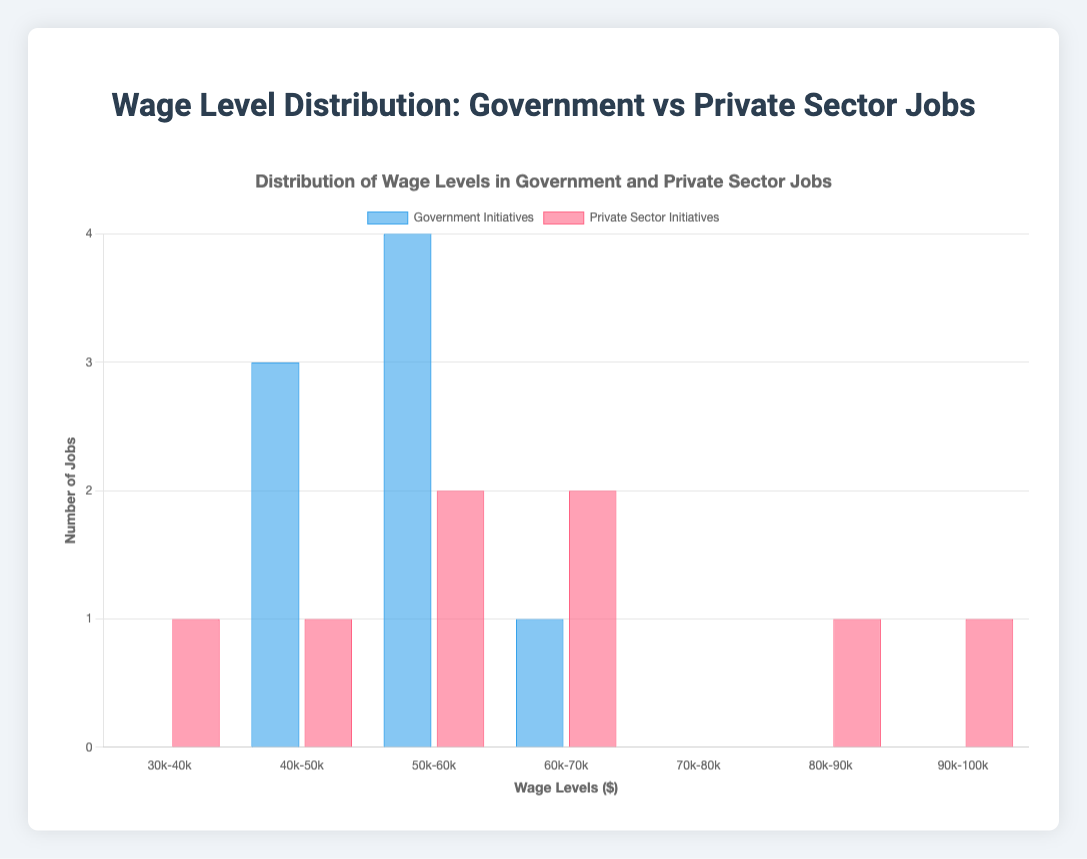What are the colors representing the two datasets? The colors used represent different datasets. The bars representing Government Initiatives are blue, and the bars representing Private Sector Initiatives are red.
Answer: Blue and red How many government initiative jobs fall in the 50k-60k wage range? Looking at the bar labeled '50k-60k,' we see the height of the blue bar (Government Initiatives) corresponds to 4.
Answer: 4 Which wage range has the highest count of private sector initiatives? By inspecting the heights of the red bars across all ranges, the wage range '90k-100k' has the tallest red bar with a count of 1 (matching the number of jobs).
Answer: 1 How many total jobs were created by private sector initiatives? Summing up the counts of the red bars: 1 (30k-40k) + 1 (40k-50k) + 2 (50k-60k) + 2 (60k-70k) + 0 (70k-80k) + 1 (80k-90k) + 1 (90k-100k) = 8.
Answer: 8 What's the difference in the number of jobs created in the 60k-70k wage range between the two initiatives? According to the 60k-70k wage range bar, the count for Government Initiatives is 1 and for Private Sector Initiatives is 2. The difference is 2 - 1 = 1.
Answer: 1 Which wage range has the greatest difference in count between government and private sector initiatives? Inspecting the height differences, the most significant difference is in the 50k-60k range with 4 (Government) - 2 (Private) = 2 jobs.
Answer: 50k-60k What's the average wage range of jobs created by government initiatives? The total number of government jobs is 8. Calculate the average by summing the mid-point of each range multiplied by the count: (0*35k + 3*45k + 4*55k + 1*65k)/8 = 50k.
Answer: 50k How many more jobs in the private sector are in the 80k-90k wage range compared to the 30k-40k wage range? The count for 80k-90k is 1 and for 30k-40k is 1 as well. The difference is 0.
Answer: 0 In which wage range do government initiatives have the same number of jobs as private sector initiatives? Examining the graph, the '40k-50k' wage range shows both blue and red bars have a height of 1.
Answer: 40k-50k Which sector has more variability in wage ranges of jobs created? The figure shows the private sector has jobs spread across all seven wage ranges, while government jobs fall within a few specific ranges. Thus, more variability in the private sector is observed.
Answer: Private Sector 